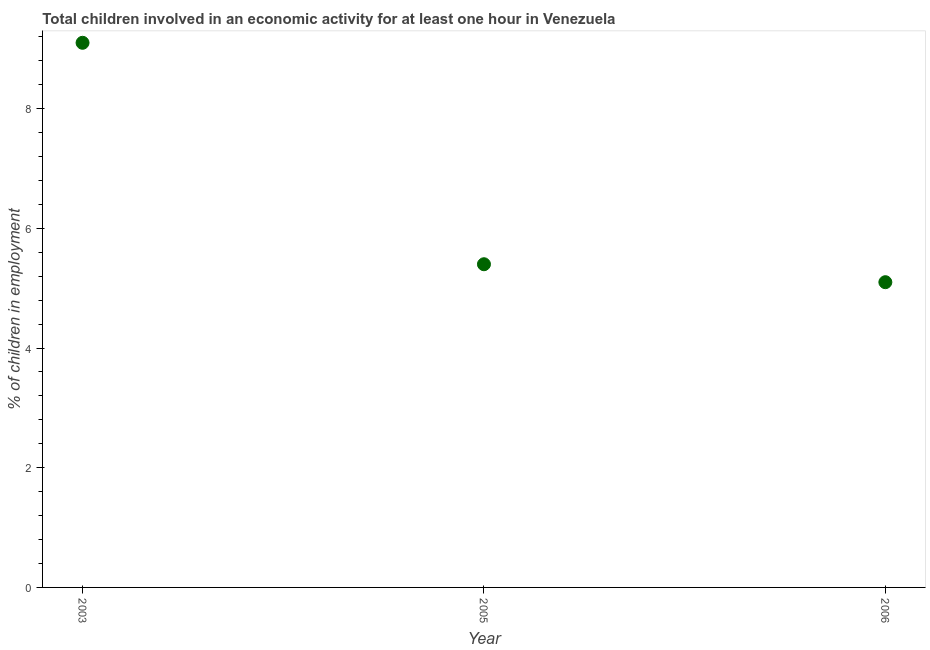Across all years, what is the minimum percentage of children in employment?
Your response must be concise. 5.1. In which year was the percentage of children in employment maximum?
Your answer should be compact. 2003. What is the sum of the percentage of children in employment?
Keep it short and to the point. 19.6. What is the difference between the percentage of children in employment in 2003 and 2005?
Offer a very short reply. 3.7. What is the average percentage of children in employment per year?
Your answer should be compact. 6.53. In how many years, is the percentage of children in employment greater than 4.8 %?
Provide a succinct answer. 3. What is the ratio of the percentage of children in employment in 2003 to that in 2006?
Make the answer very short. 1.78. What is the difference between the highest and the second highest percentage of children in employment?
Your answer should be very brief. 3.7. Is the sum of the percentage of children in employment in 2005 and 2006 greater than the maximum percentage of children in employment across all years?
Provide a succinct answer. Yes. What is the difference between the highest and the lowest percentage of children in employment?
Offer a very short reply. 4. Does the percentage of children in employment monotonically increase over the years?
Offer a terse response. No. How many dotlines are there?
Your response must be concise. 1. Are the values on the major ticks of Y-axis written in scientific E-notation?
Your response must be concise. No. Does the graph contain any zero values?
Your answer should be very brief. No. Does the graph contain grids?
Make the answer very short. No. What is the title of the graph?
Keep it short and to the point. Total children involved in an economic activity for at least one hour in Venezuela. What is the label or title of the Y-axis?
Your response must be concise. % of children in employment. What is the % of children in employment in 2003?
Give a very brief answer. 9.1. What is the difference between the % of children in employment in 2003 and 2005?
Your response must be concise. 3.7. What is the difference between the % of children in employment in 2005 and 2006?
Provide a short and direct response. 0.3. What is the ratio of the % of children in employment in 2003 to that in 2005?
Your answer should be compact. 1.69. What is the ratio of the % of children in employment in 2003 to that in 2006?
Provide a succinct answer. 1.78. What is the ratio of the % of children in employment in 2005 to that in 2006?
Your answer should be compact. 1.06. 